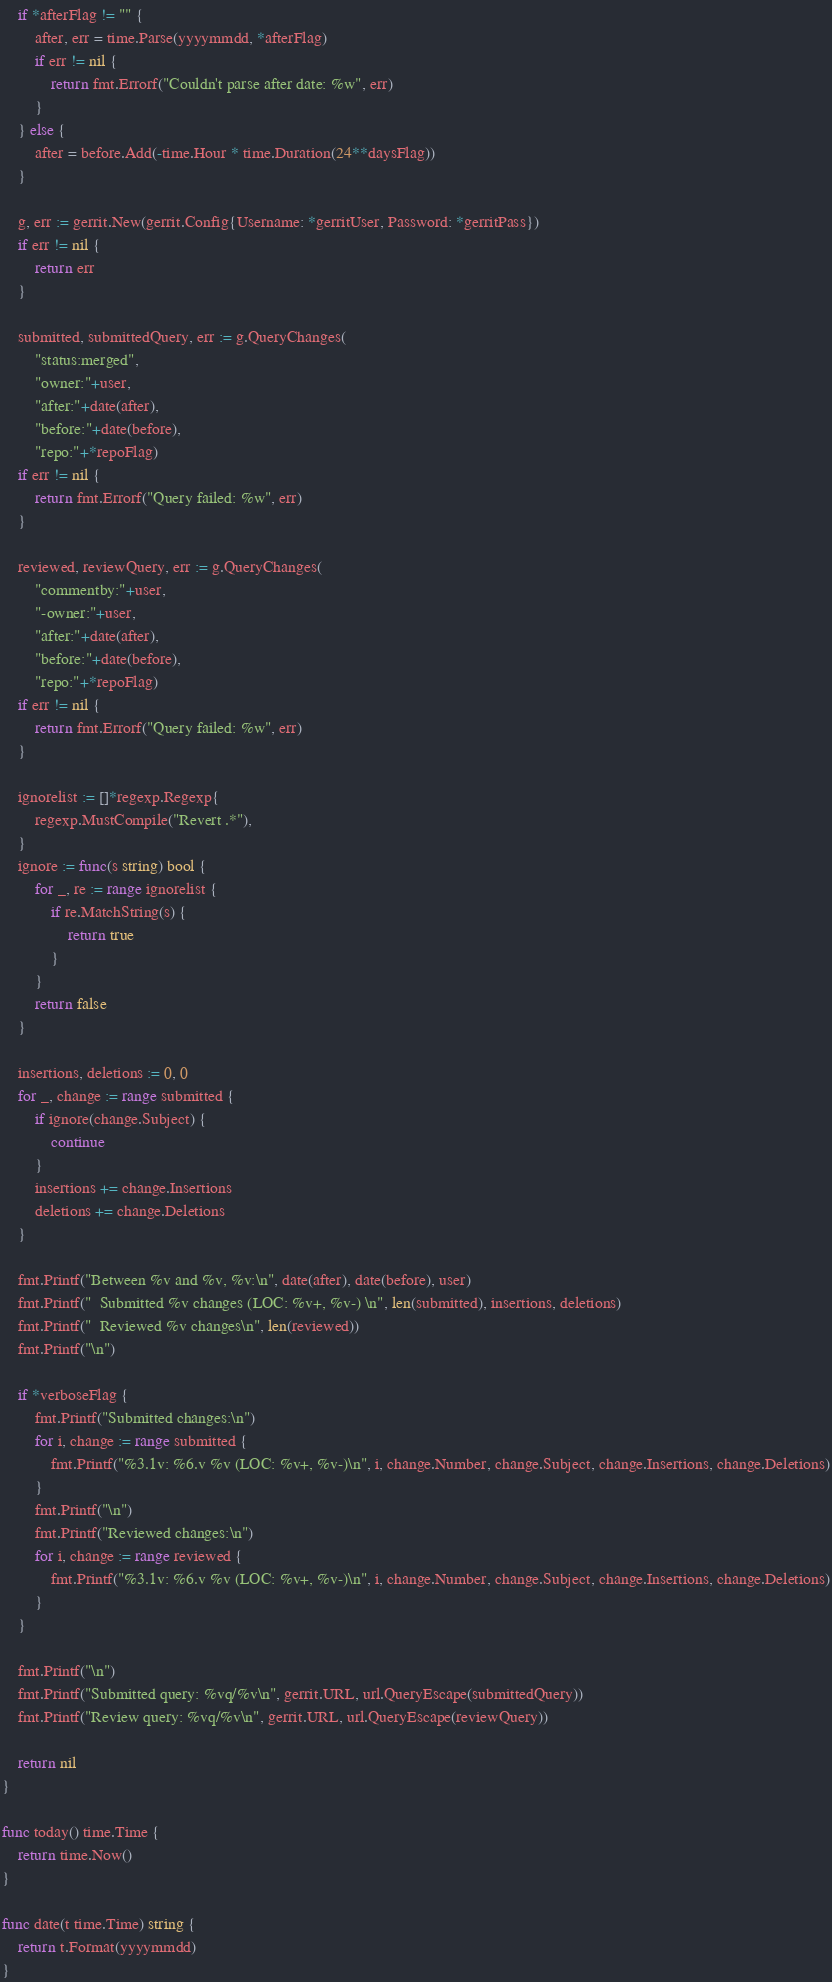Convert code to text. <code><loc_0><loc_0><loc_500><loc_500><_Go_>	if *afterFlag != "" {
		after, err = time.Parse(yyyymmdd, *afterFlag)
		if err != nil {
			return fmt.Errorf("Couldn't parse after date: %w", err)
		}
	} else {
		after = before.Add(-time.Hour * time.Duration(24**daysFlag))
	}

	g, err := gerrit.New(gerrit.Config{Username: *gerritUser, Password: *gerritPass})
	if err != nil {
		return err
	}

	submitted, submittedQuery, err := g.QueryChanges(
		"status:merged",
		"owner:"+user,
		"after:"+date(after),
		"before:"+date(before),
		"repo:"+*repoFlag)
	if err != nil {
		return fmt.Errorf("Query failed: %w", err)
	}

	reviewed, reviewQuery, err := g.QueryChanges(
		"commentby:"+user,
		"-owner:"+user,
		"after:"+date(after),
		"before:"+date(before),
		"repo:"+*repoFlag)
	if err != nil {
		return fmt.Errorf("Query failed: %w", err)
	}

	ignorelist := []*regexp.Regexp{
		regexp.MustCompile("Revert .*"),
	}
	ignore := func(s string) bool {
		for _, re := range ignorelist {
			if re.MatchString(s) {
				return true
			}
		}
		return false
	}

	insertions, deletions := 0, 0
	for _, change := range submitted {
		if ignore(change.Subject) {
			continue
		}
		insertions += change.Insertions
		deletions += change.Deletions
	}

	fmt.Printf("Between %v and %v, %v:\n", date(after), date(before), user)
	fmt.Printf("  Submitted %v changes (LOC: %v+, %v-) \n", len(submitted), insertions, deletions)
	fmt.Printf("  Reviewed %v changes\n", len(reviewed))
	fmt.Printf("\n")

	if *verboseFlag {
		fmt.Printf("Submitted changes:\n")
		for i, change := range submitted {
			fmt.Printf("%3.1v: %6.v %v (LOC: %v+, %v-)\n", i, change.Number, change.Subject, change.Insertions, change.Deletions)
		}
		fmt.Printf("\n")
		fmt.Printf("Reviewed changes:\n")
		for i, change := range reviewed {
			fmt.Printf("%3.1v: %6.v %v (LOC: %v+, %v-)\n", i, change.Number, change.Subject, change.Insertions, change.Deletions)
		}
	}

	fmt.Printf("\n")
	fmt.Printf("Submitted query: %vq/%v\n", gerrit.URL, url.QueryEscape(submittedQuery))
	fmt.Printf("Review query: %vq/%v\n", gerrit.URL, url.QueryEscape(reviewQuery))

	return nil
}

func today() time.Time {
	return time.Now()
}

func date(t time.Time) string {
	return t.Format(yyyymmdd)
}
</code> 